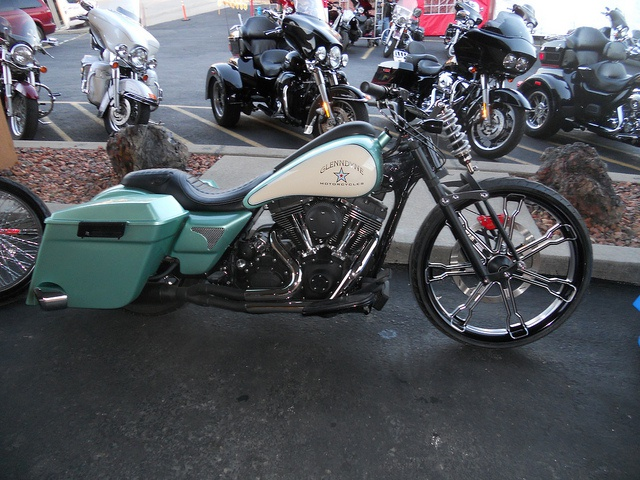Describe the objects in this image and their specific colors. I can see motorcycle in blue, black, purple, teal, and darkgray tones, motorcycle in blue, black, gray, lightgray, and darkgray tones, motorcycle in blue, black, gray, and lightgray tones, motorcycle in blue, black, and gray tones, and motorcycle in blue, lightgray, darkgray, black, and gray tones in this image. 